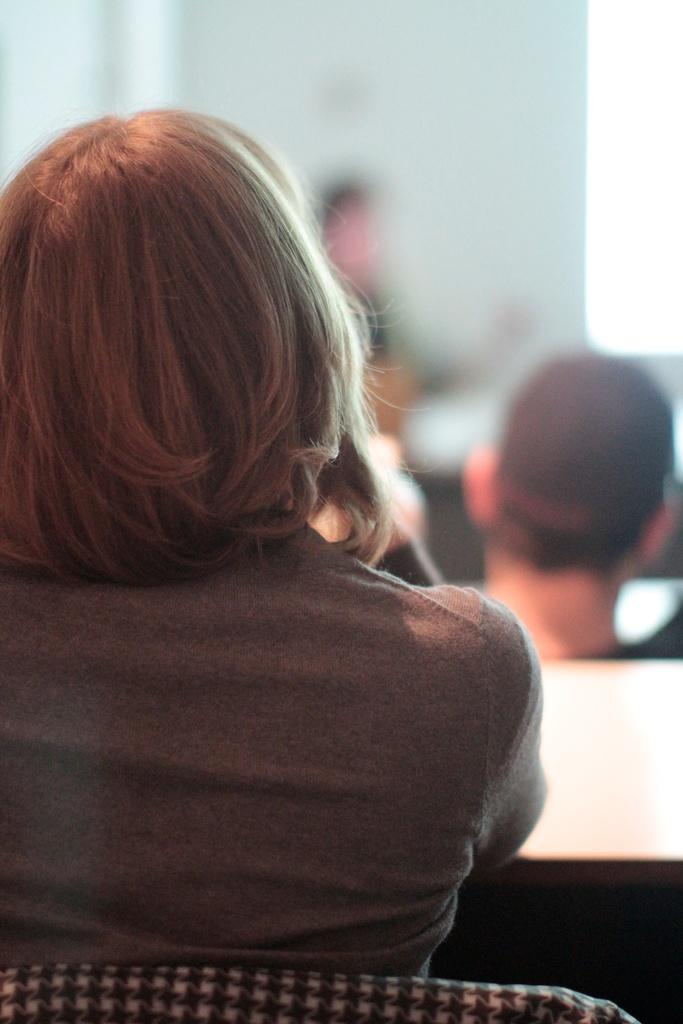Who is the main subject in the image? There is a lady in the image. Where is the lady located in the image? The lady is on the left side of the image. Can you describe the background of the image? There appear to be people in the background of the image. What color is the crayon that the lady is holding in the image? There is no crayon present in the image, so it cannot be determined what color it might be. 